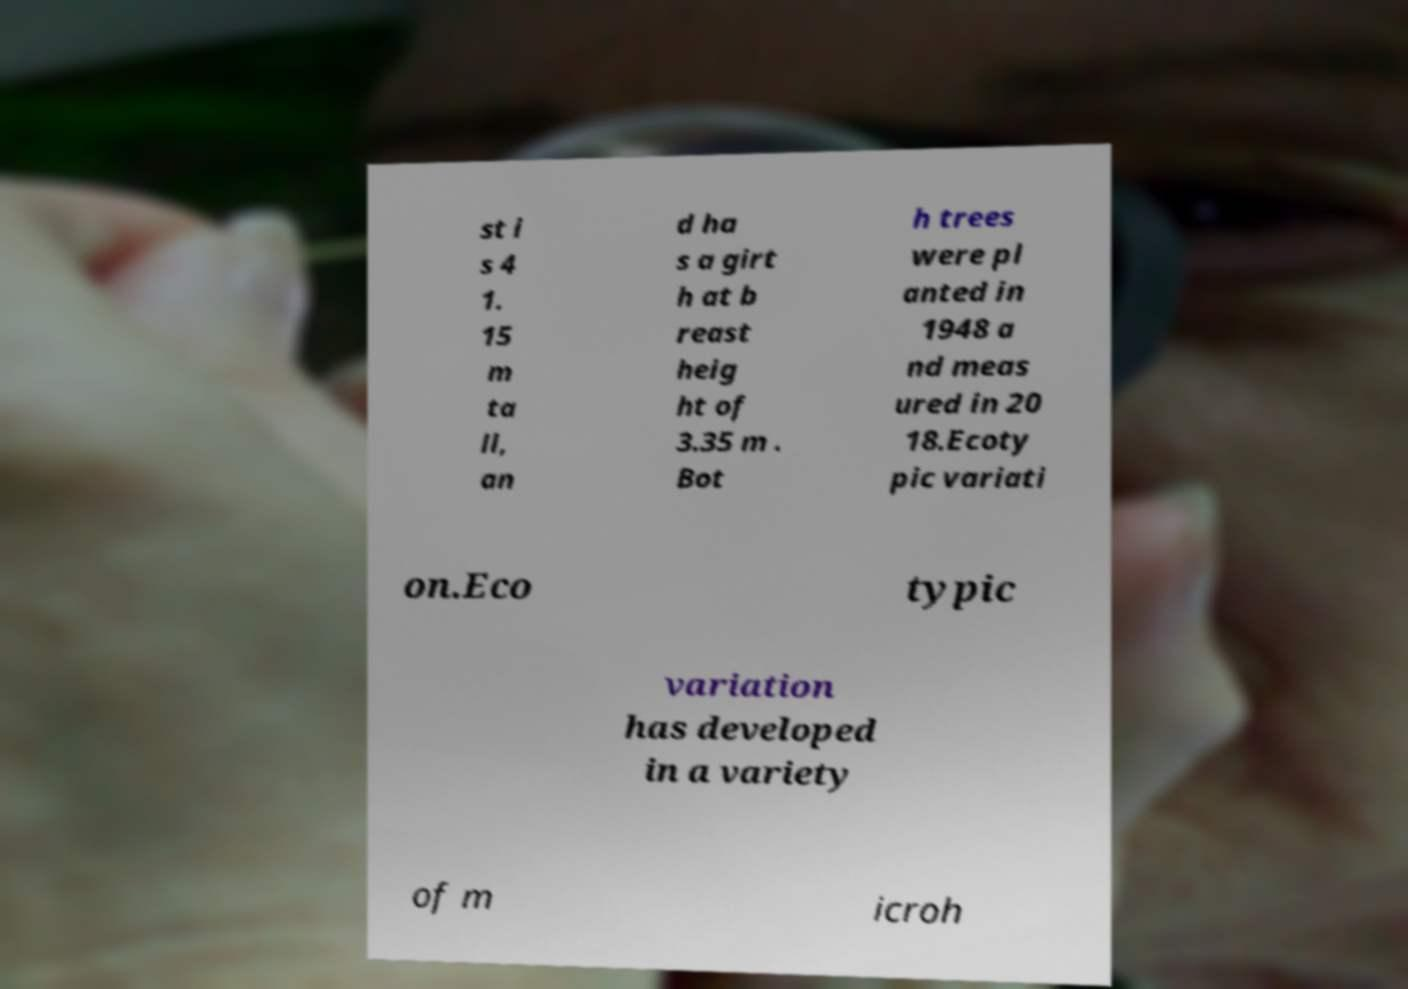Please identify and transcribe the text found in this image. st i s 4 1. 15 m ta ll, an d ha s a girt h at b reast heig ht of 3.35 m . Bot h trees were pl anted in 1948 a nd meas ured in 20 18.Ecoty pic variati on.Eco typic variation has developed in a variety of m icroh 